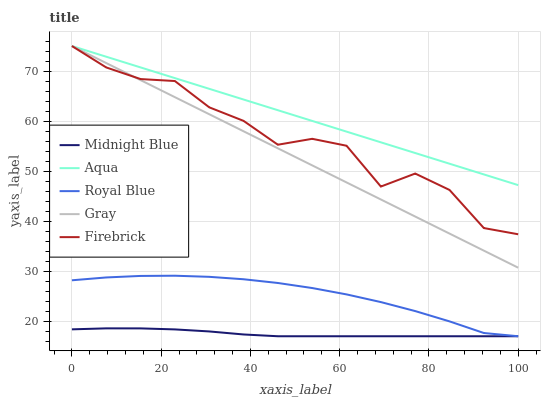Does Midnight Blue have the minimum area under the curve?
Answer yes or no. Yes. Does Aqua have the maximum area under the curve?
Answer yes or no. Yes. Does Firebrick have the minimum area under the curve?
Answer yes or no. No. Does Firebrick have the maximum area under the curve?
Answer yes or no. No. Is Aqua the smoothest?
Answer yes or no. Yes. Is Firebrick the roughest?
Answer yes or no. Yes. Is Firebrick the smoothest?
Answer yes or no. No. Is Aqua the roughest?
Answer yes or no. No. Does Royal Blue have the lowest value?
Answer yes or no. Yes. Does Firebrick have the lowest value?
Answer yes or no. No. Does Gray have the highest value?
Answer yes or no. Yes. Does Midnight Blue have the highest value?
Answer yes or no. No. Is Royal Blue less than Aqua?
Answer yes or no. Yes. Is Aqua greater than Royal Blue?
Answer yes or no. Yes. Does Midnight Blue intersect Royal Blue?
Answer yes or no. Yes. Is Midnight Blue less than Royal Blue?
Answer yes or no. No. Is Midnight Blue greater than Royal Blue?
Answer yes or no. No. Does Royal Blue intersect Aqua?
Answer yes or no. No. 